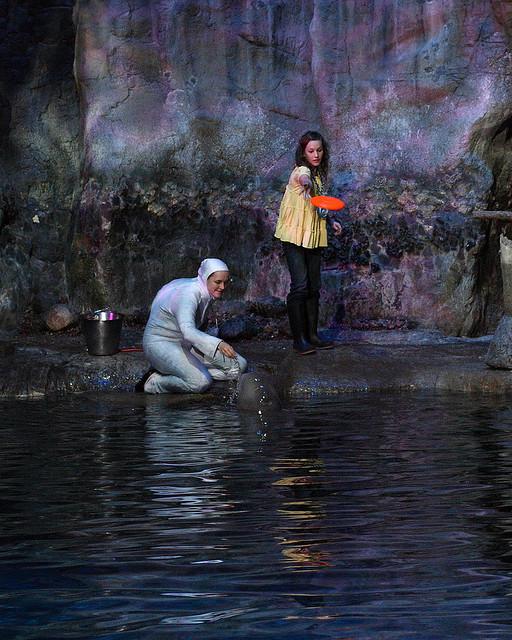How many people?
Be succinct. 2. What color is the top of the girl on the right?
Write a very short answer. Yellow. What is the color of freebee?
Give a very brief answer. Orange. 